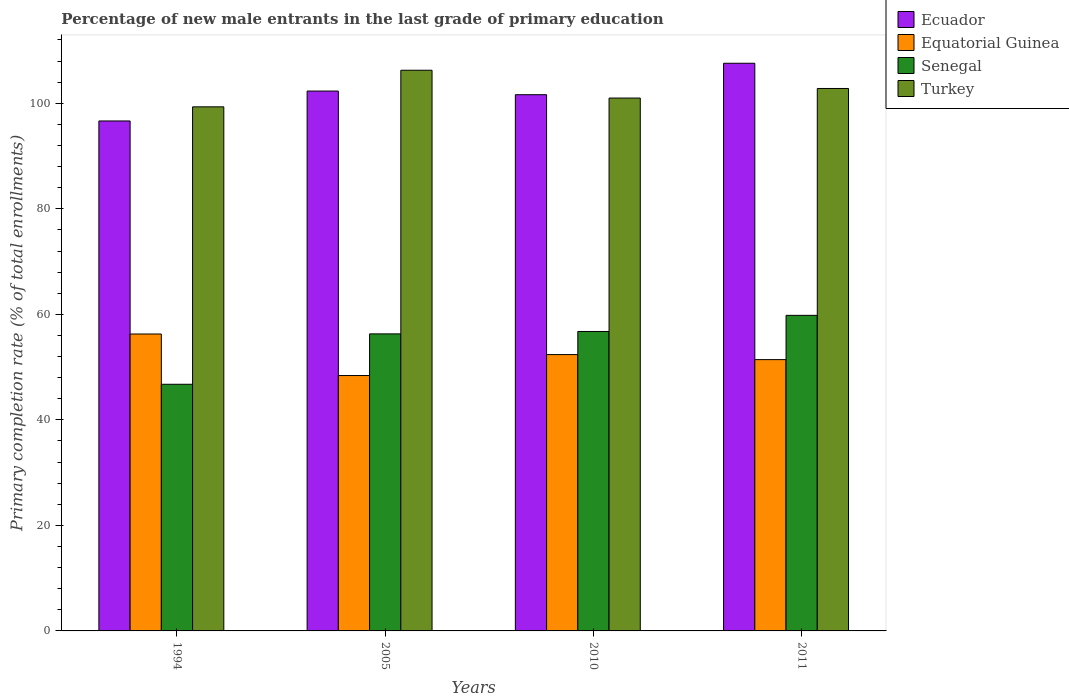How many different coloured bars are there?
Offer a terse response. 4. How many bars are there on the 4th tick from the left?
Your response must be concise. 4. How many bars are there on the 2nd tick from the right?
Provide a succinct answer. 4. What is the label of the 4th group of bars from the left?
Provide a succinct answer. 2011. In how many cases, is the number of bars for a given year not equal to the number of legend labels?
Make the answer very short. 0. What is the percentage of new male entrants in Turkey in 2011?
Offer a terse response. 102.81. Across all years, what is the maximum percentage of new male entrants in Turkey?
Offer a terse response. 106.26. Across all years, what is the minimum percentage of new male entrants in Senegal?
Your response must be concise. 46.74. What is the total percentage of new male entrants in Equatorial Guinea in the graph?
Your response must be concise. 208.46. What is the difference between the percentage of new male entrants in Senegal in 2005 and that in 2010?
Provide a short and direct response. -0.46. What is the difference between the percentage of new male entrants in Turkey in 2005 and the percentage of new male entrants in Equatorial Guinea in 1994?
Your answer should be very brief. 49.99. What is the average percentage of new male entrants in Ecuador per year?
Give a very brief answer. 102.04. In the year 2010, what is the difference between the percentage of new male entrants in Ecuador and percentage of new male entrants in Turkey?
Offer a very short reply. 0.64. What is the ratio of the percentage of new male entrants in Senegal in 1994 to that in 2010?
Offer a very short reply. 0.82. Is the difference between the percentage of new male entrants in Ecuador in 2010 and 2011 greater than the difference between the percentage of new male entrants in Turkey in 2010 and 2011?
Offer a terse response. No. What is the difference between the highest and the second highest percentage of new male entrants in Turkey?
Provide a succinct answer. 3.45. What is the difference between the highest and the lowest percentage of new male entrants in Senegal?
Offer a very short reply. 13.06. Is the sum of the percentage of new male entrants in Senegal in 2010 and 2011 greater than the maximum percentage of new male entrants in Equatorial Guinea across all years?
Your answer should be compact. Yes. Is it the case that in every year, the sum of the percentage of new male entrants in Turkey and percentage of new male entrants in Ecuador is greater than the sum of percentage of new male entrants in Senegal and percentage of new male entrants in Equatorial Guinea?
Your answer should be very brief. No. What does the 4th bar from the right in 1994 represents?
Your answer should be very brief. Ecuador. Is it the case that in every year, the sum of the percentage of new male entrants in Turkey and percentage of new male entrants in Equatorial Guinea is greater than the percentage of new male entrants in Senegal?
Your response must be concise. Yes. Are all the bars in the graph horizontal?
Ensure brevity in your answer.  No. How many years are there in the graph?
Keep it short and to the point. 4. What is the difference between two consecutive major ticks on the Y-axis?
Offer a terse response. 20. Are the values on the major ticks of Y-axis written in scientific E-notation?
Provide a short and direct response. No. How many legend labels are there?
Give a very brief answer. 4. How are the legend labels stacked?
Offer a terse response. Vertical. What is the title of the graph?
Your answer should be very brief. Percentage of new male entrants in the last grade of primary education. Does "Mongolia" appear as one of the legend labels in the graph?
Provide a succinct answer. No. What is the label or title of the Y-axis?
Keep it short and to the point. Primary completion rate (% of total enrollments). What is the Primary completion rate (% of total enrollments) of Ecuador in 1994?
Your response must be concise. 96.65. What is the Primary completion rate (% of total enrollments) of Equatorial Guinea in 1994?
Ensure brevity in your answer.  56.27. What is the Primary completion rate (% of total enrollments) in Senegal in 1994?
Keep it short and to the point. 46.74. What is the Primary completion rate (% of total enrollments) in Turkey in 1994?
Give a very brief answer. 99.32. What is the Primary completion rate (% of total enrollments) of Ecuador in 2005?
Your answer should be very brief. 102.31. What is the Primary completion rate (% of total enrollments) of Equatorial Guinea in 2005?
Ensure brevity in your answer.  48.4. What is the Primary completion rate (% of total enrollments) of Senegal in 2005?
Ensure brevity in your answer.  56.29. What is the Primary completion rate (% of total enrollments) in Turkey in 2005?
Provide a succinct answer. 106.26. What is the Primary completion rate (% of total enrollments) of Ecuador in 2010?
Your answer should be very brief. 101.63. What is the Primary completion rate (% of total enrollments) in Equatorial Guinea in 2010?
Offer a very short reply. 52.37. What is the Primary completion rate (% of total enrollments) in Senegal in 2010?
Make the answer very short. 56.75. What is the Primary completion rate (% of total enrollments) of Turkey in 2010?
Give a very brief answer. 100.99. What is the Primary completion rate (% of total enrollments) of Ecuador in 2011?
Give a very brief answer. 107.58. What is the Primary completion rate (% of total enrollments) of Equatorial Guinea in 2011?
Provide a short and direct response. 51.42. What is the Primary completion rate (% of total enrollments) of Senegal in 2011?
Make the answer very short. 59.81. What is the Primary completion rate (% of total enrollments) of Turkey in 2011?
Provide a short and direct response. 102.81. Across all years, what is the maximum Primary completion rate (% of total enrollments) of Ecuador?
Ensure brevity in your answer.  107.58. Across all years, what is the maximum Primary completion rate (% of total enrollments) of Equatorial Guinea?
Your answer should be very brief. 56.27. Across all years, what is the maximum Primary completion rate (% of total enrollments) in Senegal?
Give a very brief answer. 59.81. Across all years, what is the maximum Primary completion rate (% of total enrollments) in Turkey?
Keep it short and to the point. 106.26. Across all years, what is the minimum Primary completion rate (% of total enrollments) in Ecuador?
Your answer should be compact. 96.65. Across all years, what is the minimum Primary completion rate (% of total enrollments) in Equatorial Guinea?
Make the answer very short. 48.4. Across all years, what is the minimum Primary completion rate (% of total enrollments) of Senegal?
Your answer should be very brief. 46.74. Across all years, what is the minimum Primary completion rate (% of total enrollments) in Turkey?
Your response must be concise. 99.32. What is the total Primary completion rate (% of total enrollments) in Ecuador in the graph?
Offer a very short reply. 408.17. What is the total Primary completion rate (% of total enrollments) of Equatorial Guinea in the graph?
Offer a terse response. 208.46. What is the total Primary completion rate (% of total enrollments) of Senegal in the graph?
Provide a succinct answer. 219.59. What is the total Primary completion rate (% of total enrollments) of Turkey in the graph?
Your response must be concise. 409.38. What is the difference between the Primary completion rate (% of total enrollments) in Ecuador in 1994 and that in 2005?
Your answer should be very brief. -5.67. What is the difference between the Primary completion rate (% of total enrollments) of Equatorial Guinea in 1994 and that in 2005?
Make the answer very short. 7.87. What is the difference between the Primary completion rate (% of total enrollments) in Senegal in 1994 and that in 2005?
Your answer should be very brief. -9.55. What is the difference between the Primary completion rate (% of total enrollments) in Turkey in 1994 and that in 2005?
Give a very brief answer. -6.93. What is the difference between the Primary completion rate (% of total enrollments) in Ecuador in 1994 and that in 2010?
Offer a terse response. -4.98. What is the difference between the Primary completion rate (% of total enrollments) of Equatorial Guinea in 1994 and that in 2010?
Provide a short and direct response. 3.9. What is the difference between the Primary completion rate (% of total enrollments) in Senegal in 1994 and that in 2010?
Make the answer very short. -10.01. What is the difference between the Primary completion rate (% of total enrollments) of Turkey in 1994 and that in 2010?
Ensure brevity in your answer.  -1.66. What is the difference between the Primary completion rate (% of total enrollments) in Ecuador in 1994 and that in 2011?
Your answer should be compact. -10.94. What is the difference between the Primary completion rate (% of total enrollments) in Equatorial Guinea in 1994 and that in 2011?
Give a very brief answer. 4.86. What is the difference between the Primary completion rate (% of total enrollments) in Senegal in 1994 and that in 2011?
Keep it short and to the point. -13.06. What is the difference between the Primary completion rate (% of total enrollments) in Turkey in 1994 and that in 2011?
Offer a very short reply. -3.48. What is the difference between the Primary completion rate (% of total enrollments) in Ecuador in 2005 and that in 2010?
Offer a very short reply. 0.69. What is the difference between the Primary completion rate (% of total enrollments) in Equatorial Guinea in 2005 and that in 2010?
Give a very brief answer. -3.97. What is the difference between the Primary completion rate (% of total enrollments) of Senegal in 2005 and that in 2010?
Your answer should be compact. -0.46. What is the difference between the Primary completion rate (% of total enrollments) of Turkey in 2005 and that in 2010?
Give a very brief answer. 5.27. What is the difference between the Primary completion rate (% of total enrollments) in Ecuador in 2005 and that in 2011?
Offer a terse response. -5.27. What is the difference between the Primary completion rate (% of total enrollments) of Equatorial Guinea in 2005 and that in 2011?
Ensure brevity in your answer.  -3.02. What is the difference between the Primary completion rate (% of total enrollments) of Senegal in 2005 and that in 2011?
Your answer should be very brief. -3.51. What is the difference between the Primary completion rate (% of total enrollments) in Turkey in 2005 and that in 2011?
Your response must be concise. 3.45. What is the difference between the Primary completion rate (% of total enrollments) in Ecuador in 2010 and that in 2011?
Give a very brief answer. -5.96. What is the difference between the Primary completion rate (% of total enrollments) in Equatorial Guinea in 2010 and that in 2011?
Keep it short and to the point. 0.95. What is the difference between the Primary completion rate (% of total enrollments) in Senegal in 2010 and that in 2011?
Your answer should be very brief. -3.06. What is the difference between the Primary completion rate (% of total enrollments) of Turkey in 2010 and that in 2011?
Provide a succinct answer. -1.82. What is the difference between the Primary completion rate (% of total enrollments) of Ecuador in 1994 and the Primary completion rate (% of total enrollments) of Equatorial Guinea in 2005?
Ensure brevity in your answer.  48.25. What is the difference between the Primary completion rate (% of total enrollments) in Ecuador in 1994 and the Primary completion rate (% of total enrollments) in Senegal in 2005?
Your answer should be very brief. 40.35. What is the difference between the Primary completion rate (% of total enrollments) of Ecuador in 1994 and the Primary completion rate (% of total enrollments) of Turkey in 2005?
Provide a short and direct response. -9.61. What is the difference between the Primary completion rate (% of total enrollments) in Equatorial Guinea in 1994 and the Primary completion rate (% of total enrollments) in Senegal in 2005?
Give a very brief answer. -0.02. What is the difference between the Primary completion rate (% of total enrollments) of Equatorial Guinea in 1994 and the Primary completion rate (% of total enrollments) of Turkey in 2005?
Give a very brief answer. -49.99. What is the difference between the Primary completion rate (% of total enrollments) of Senegal in 1994 and the Primary completion rate (% of total enrollments) of Turkey in 2005?
Your answer should be compact. -59.51. What is the difference between the Primary completion rate (% of total enrollments) in Ecuador in 1994 and the Primary completion rate (% of total enrollments) in Equatorial Guinea in 2010?
Offer a terse response. 44.28. What is the difference between the Primary completion rate (% of total enrollments) in Ecuador in 1994 and the Primary completion rate (% of total enrollments) in Senegal in 2010?
Provide a short and direct response. 39.9. What is the difference between the Primary completion rate (% of total enrollments) of Ecuador in 1994 and the Primary completion rate (% of total enrollments) of Turkey in 2010?
Provide a succinct answer. -4.34. What is the difference between the Primary completion rate (% of total enrollments) in Equatorial Guinea in 1994 and the Primary completion rate (% of total enrollments) in Senegal in 2010?
Your answer should be compact. -0.48. What is the difference between the Primary completion rate (% of total enrollments) in Equatorial Guinea in 1994 and the Primary completion rate (% of total enrollments) in Turkey in 2010?
Provide a succinct answer. -44.72. What is the difference between the Primary completion rate (% of total enrollments) in Senegal in 1994 and the Primary completion rate (% of total enrollments) in Turkey in 2010?
Provide a succinct answer. -54.24. What is the difference between the Primary completion rate (% of total enrollments) in Ecuador in 1994 and the Primary completion rate (% of total enrollments) in Equatorial Guinea in 2011?
Ensure brevity in your answer.  45.23. What is the difference between the Primary completion rate (% of total enrollments) of Ecuador in 1994 and the Primary completion rate (% of total enrollments) of Senegal in 2011?
Provide a succinct answer. 36.84. What is the difference between the Primary completion rate (% of total enrollments) in Ecuador in 1994 and the Primary completion rate (% of total enrollments) in Turkey in 2011?
Make the answer very short. -6.16. What is the difference between the Primary completion rate (% of total enrollments) of Equatorial Guinea in 1994 and the Primary completion rate (% of total enrollments) of Senegal in 2011?
Ensure brevity in your answer.  -3.53. What is the difference between the Primary completion rate (% of total enrollments) of Equatorial Guinea in 1994 and the Primary completion rate (% of total enrollments) of Turkey in 2011?
Keep it short and to the point. -46.53. What is the difference between the Primary completion rate (% of total enrollments) of Senegal in 1994 and the Primary completion rate (% of total enrollments) of Turkey in 2011?
Keep it short and to the point. -56.06. What is the difference between the Primary completion rate (% of total enrollments) in Ecuador in 2005 and the Primary completion rate (% of total enrollments) in Equatorial Guinea in 2010?
Keep it short and to the point. 49.94. What is the difference between the Primary completion rate (% of total enrollments) of Ecuador in 2005 and the Primary completion rate (% of total enrollments) of Senegal in 2010?
Provide a short and direct response. 45.57. What is the difference between the Primary completion rate (% of total enrollments) of Ecuador in 2005 and the Primary completion rate (% of total enrollments) of Turkey in 2010?
Provide a short and direct response. 1.33. What is the difference between the Primary completion rate (% of total enrollments) in Equatorial Guinea in 2005 and the Primary completion rate (% of total enrollments) in Senegal in 2010?
Ensure brevity in your answer.  -8.35. What is the difference between the Primary completion rate (% of total enrollments) of Equatorial Guinea in 2005 and the Primary completion rate (% of total enrollments) of Turkey in 2010?
Your response must be concise. -52.59. What is the difference between the Primary completion rate (% of total enrollments) of Senegal in 2005 and the Primary completion rate (% of total enrollments) of Turkey in 2010?
Your answer should be very brief. -44.69. What is the difference between the Primary completion rate (% of total enrollments) in Ecuador in 2005 and the Primary completion rate (% of total enrollments) in Equatorial Guinea in 2011?
Your answer should be very brief. 50.9. What is the difference between the Primary completion rate (% of total enrollments) of Ecuador in 2005 and the Primary completion rate (% of total enrollments) of Senegal in 2011?
Offer a very short reply. 42.51. What is the difference between the Primary completion rate (% of total enrollments) of Ecuador in 2005 and the Primary completion rate (% of total enrollments) of Turkey in 2011?
Keep it short and to the point. -0.49. What is the difference between the Primary completion rate (% of total enrollments) of Equatorial Guinea in 2005 and the Primary completion rate (% of total enrollments) of Senegal in 2011?
Ensure brevity in your answer.  -11.41. What is the difference between the Primary completion rate (% of total enrollments) of Equatorial Guinea in 2005 and the Primary completion rate (% of total enrollments) of Turkey in 2011?
Your response must be concise. -54.41. What is the difference between the Primary completion rate (% of total enrollments) in Senegal in 2005 and the Primary completion rate (% of total enrollments) in Turkey in 2011?
Give a very brief answer. -46.51. What is the difference between the Primary completion rate (% of total enrollments) of Ecuador in 2010 and the Primary completion rate (% of total enrollments) of Equatorial Guinea in 2011?
Offer a very short reply. 50.21. What is the difference between the Primary completion rate (% of total enrollments) in Ecuador in 2010 and the Primary completion rate (% of total enrollments) in Senegal in 2011?
Offer a very short reply. 41.82. What is the difference between the Primary completion rate (% of total enrollments) in Ecuador in 2010 and the Primary completion rate (% of total enrollments) in Turkey in 2011?
Give a very brief answer. -1.18. What is the difference between the Primary completion rate (% of total enrollments) in Equatorial Guinea in 2010 and the Primary completion rate (% of total enrollments) in Senegal in 2011?
Keep it short and to the point. -7.44. What is the difference between the Primary completion rate (% of total enrollments) of Equatorial Guinea in 2010 and the Primary completion rate (% of total enrollments) of Turkey in 2011?
Your answer should be compact. -50.43. What is the difference between the Primary completion rate (% of total enrollments) of Senegal in 2010 and the Primary completion rate (% of total enrollments) of Turkey in 2011?
Keep it short and to the point. -46.06. What is the average Primary completion rate (% of total enrollments) in Ecuador per year?
Make the answer very short. 102.04. What is the average Primary completion rate (% of total enrollments) of Equatorial Guinea per year?
Provide a succinct answer. 52.11. What is the average Primary completion rate (% of total enrollments) of Senegal per year?
Keep it short and to the point. 54.9. What is the average Primary completion rate (% of total enrollments) of Turkey per year?
Ensure brevity in your answer.  102.34. In the year 1994, what is the difference between the Primary completion rate (% of total enrollments) in Ecuador and Primary completion rate (% of total enrollments) in Equatorial Guinea?
Your answer should be compact. 40.37. In the year 1994, what is the difference between the Primary completion rate (% of total enrollments) of Ecuador and Primary completion rate (% of total enrollments) of Senegal?
Make the answer very short. 49.9. In the year 1994, what is the difference between the Primary completion rate (% of total enrollments) in Ecuador and Primary completion rate (% of total enrollments) in Turkey?
Provide a short and direct response. -2.68. In the year 1994, what is the difference between the Primary completion rate (% of total enrollments) of Equatorial Guinea and Primary completion rate (% of total enrollments) of Senegal?
Your answer should be very brief. 9.53. In the year 1994, what is the difference between the Primary completion rate (% of total enrollments) in Equatorial Guinea and Primary completion rate (% of total enrollments) in Turkey?
Provide a short and direct response. -43.05. In the year 1994, what is the difference between the Primary completion rate (% of total enrollments) of Senegal and Primary completion rate (% of total enrollments) of Turkey?
Your answer should be very brief. -52.58. In the year 2005, what is the difference between the Primary completion rate (% of total enrollments) in Ecuador and Primary completion rate (% of total enrollments) in Equatorial Guinea?
Offer a very short reply. 53.91. In the year 2005, what is the difference between the Primary completion rate (% of total enrollments) in Ecuador and Primary completion rate (% of total enrollments) in Senegal?
Offer a very short reply. 46.02. In the year 2005, what is the difference between the Primary completion rate (% of total enrollments) of Ecuador and Primary completion rate (% of total enrollments) of Turkey?
Provide a succinct answer. -3.94. In the year 2005, what is the difference between the Primary completion rate (% of total enrollments) in Equatorial Guinea and Primary completion rate (% of total enrollments) in Senegal?
Your response must be concise. -7.89. In the year 2005, what is the difference between the Primary completion rate (% of total enrollments) in Equatorial Guinea and Primary completion rate (% of total enrollments) in Turkey?
Your response must be concise. -57.86. In the year 2005, what is the difference between the Primary completion rate (% of total enrollments) of Senegal and Primary completion rate (% of total enrollments) of Turkey?
Offer a very short reply. -49.97. In the year 2010, what is the difference between the Primary completion rate (% of total enrollments) of Ecuador and Primary completion rate (% of total enrollments) of Equatorial Guinea?
Provide a short and direct response. 49.26. In the year 2010, what is the difference between the Primary completion rate (% of total enrollments) of Ecuador and Primary completion rate (% of total enrollments) of Senegal?
Provide a short and direct response. 44.88. In the year 2010, what is the difference between the Primary completion rate (% of total enrollments) in Ecuador and Primary completion rate (% of total enrollments) in Turkey?
Give a very brief answer. 0.64. In the year 2010, what is the difference between the Primary completion rate (% of total enrollments) of Equatorial Guinea and Primary completion rate (% of total enrollments) of Senegal?
Offer a terse response. -4.38. In the year 2010, what is the difference between the Primary completion rate (% of total enrollments) in Equatorial Guinea and Primary completion rate (% of total enrollments) in Turkey?
Offer a terse response. -48.62. In the year 2010, what is the difference between the Primary completion rate (% of total enrollments) of Senegal and Primary completion rate (% of total enrollments) of Turkey?
Your answer should be compact. -44.24. In the year 2011, what is the difference between the Primary completion rate (% of total enrollments) of Ecuador and Primary completion rate (% of total enrollments) of Equatorial Guinea?
Provide a succinct answer. 56.17. In the year 2011, what is the difference between the Primary completion rate (% of total enrollments) in Ecuador and Primary completion rate (% of total enrollments) in Senegal?
Make the answer very short. 47.78. In the year 2011, what is the difference between the Primary completion rate (% of total enrollments) in Ecuador and Primary completion rate (% of total enrollments) in Turkey?
Give a very brief answer. 4.78. In the year 2011, what is the difference between the Primary completion rate (% of total enrollments) in Equatorial Guinea and Primary completion rate (% of total enrollments) in Senegal?
Ensure brevity in your answer.  -8.39. In the year 2011, what is the difference between the Primary completion rate (% of total enrollments) of Equatorial Guinea and Primary completion rate (% of total enrollments) of Turkey?
Your response must be concise. -51.39. In the year 2011, what is the difference between the Primary completion rate (% of total enrollments) of Senegal and Primary completion rate (% of total enrollments) of Turkey?
Your answer should be very brief. -43. What is the ratio of the Primary completion rate (% of total enrollments) of Ecuador in 1994 to that in 2005?
Keep it short and to the point. 0.94. What is the ratio of the Primary completion rate (% of total enrollments) in Equatorial Guinea in 1994 to that in 2005?
Your response must be concise. 1.16. What is the ratio of the Primary completion rate (% of total enrollments) of Senegal in 1994 to that in 2005?
Keep it short and to the point. 0.83. What is the ratio of the Primary completion rate (% of total enrollments) in Turkey in 1994 to that in 2005?
Offer a very short reply. 0.93. What is the ratio of the Primary completion rate (% of total enrollments) in Ecuador in 1994 to that in 2010?
Keep it short and to the point. 0.95. What is the ratio of the Primary completion rate (% of total enrollments) of Equatorial Guinea in 1994 to that in 2010?
Provide a succinct answer. 1.07. What is the ratio of the Primary completion rate (% of total enrollments) of Senegal in 1994 to that in 2010?
Offer a terse response. 0.82. What is the ratio of the Primary completion rate (% of total enrollments) in Turkey in 1994 to that in 2010?
Your response must be concise. 0.98. What is the ratio of the Primary completion rate (% of total enrollments) in Ecuador in 1994 to that in 2011?
Your answer should be compact. 0.9. What is the ratio of the Primary completion rate (% of total enrollments) in Equatorial Guinea in 1994 to that in 2011?
Offer a terse response. 1.09. What is the ratio of the Primary completion rate (% of total enrollments) in Senegal in 1994 to that in 2011?
Give a very brief answer. 0.78. What is the ratio of the Primary completion rate (% of total enrollments) in Turkey in 1994 to that in 2011?
Keep it short and to the point. 0.97. What is the ratio of the Primary completion rate (% of total enrollments) of Ecuador in 2005 to that in 2010?
Make the answer very short. 1.01. What is the ratio of the Primary completion rate (% of total enrollments) in Equatorial Guinea in 2005 to that in 2010?
Keep it short and to the point. 0.92. What is the ratio of the Primary completion rate (% of total enrollments) of Senegal in 2005 to that in 2010?
Provide a short and direct response. 0.99. What is the ratio of the Primary completion rate (% of total enrollments) in Turkey in 2005 to that in 2010?
Offer a terse response. 1.05. What is the ratio of the Primary completion rate (% of total enrollments) of Ecuador in 2005 to that in 2011?
Offer a very short reply. 0.95. What is the ratio of the Primary completion rate (% of total enrollments) of Equatorial Guinea in 2005 to that in 2011?
Your response must be concise. 0.94. What is the ratio of the Primary completion rate (% of total enrollments) of Senegal in 2005 to that in 2011?
Your answer should be compact. 0.94. What is the ratio of the Primary completion rate (% of total enrollments) in Turkey in 2005 to that in 2011?
Your response must be concise. 1.03. What is the ratio of the Primary completion rate (% of total enrollments) in Ecuador in 2010 to that in 2011?
Give a very brief answer. 0.94. What is the ratio of the Primary completion rate (% of total enrollments) of Equatorial Guinea in 2010 to that in 2011?
Your response must be concise. 1.02. What is the ratio of the Primary completion rate (% of total enrollments) of Senegal in 2010 to that in 2011?
Make the answer very short. 0.95. What is the ratio of the Primary completion rate (% of total enrollments) in Turkey in 2010 to that in 2011?
Your answer should be compact. 0.98. What is the difference between the highest and the second highest Primary completion rate (% of total enrollments) in Ecuador?
Give a very brief answer. 5.27. What is the difference between the highest and the second highest Primary completion rate (% of total enrollments) in Equatorial Guinea?
Your answer should be very brief. 3.9. What is the difference between the highest and the second highest Primary completion rate (% of total enrollments) of Senegal?
Give a very brief answer. 3.06. What is the difference between the highest and the second highest Primary completion rate (% of total enrollments) of Turkey?
Ensure brevity in your answer.  3.45. What is the difference between the highest and the lowest Primary completion rate (% of total enrollments) of Ecuador?
Offer a very short reply. 10.94. What is the difference between the highest and the lowest Primary completion rate (% of total enrollments) of Equatorial Guinea?
Provide a succinct answer. 7.87. What is the difference between the highest and the lowest Primary completion rate (% of total enrollments) in Senegal?
Your answer should be compact. 13.06. What is the difference between the highest and the lowest Primary completion rate (% of total enrollments) in Turkey?
Give a very brief answer. 6.93. 